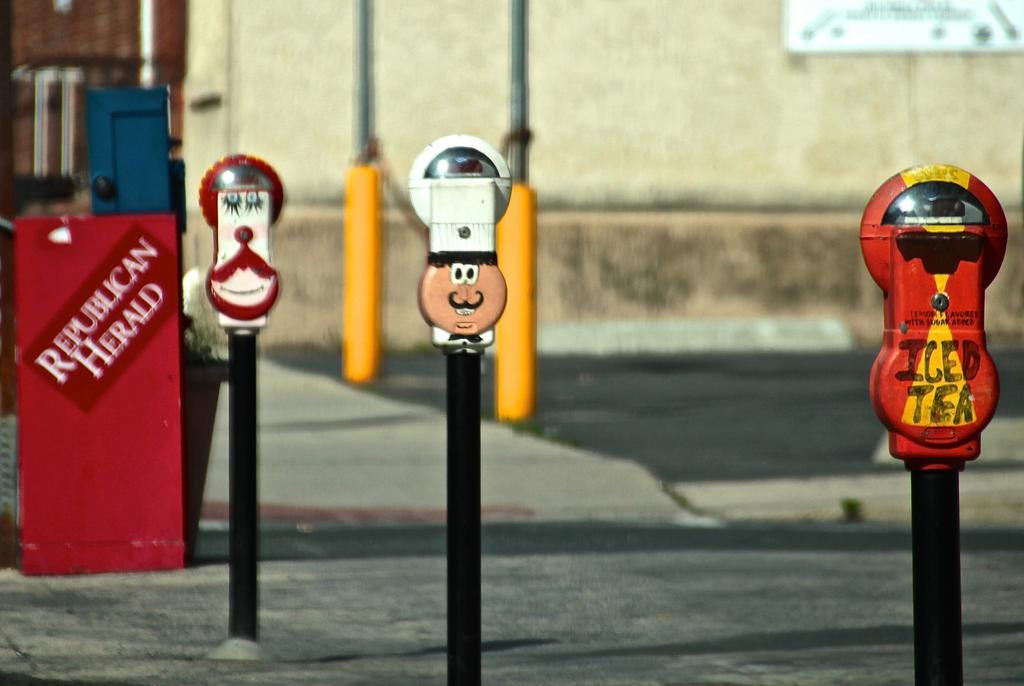What is the name of the newspaper?
Your answer should be very brief. Republican herald. What newspaper is the vending machine for?
Offer a very short reply. Republican herald. 